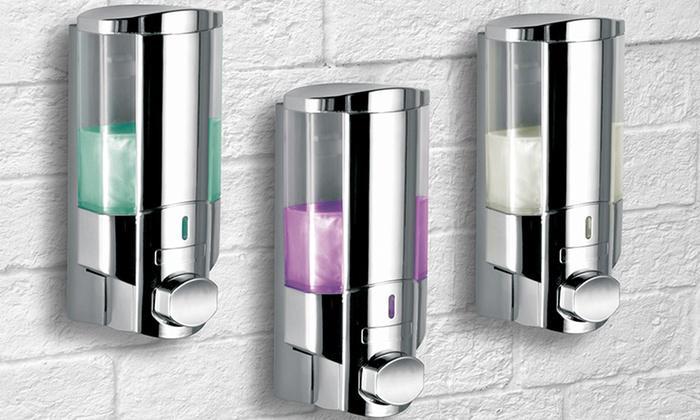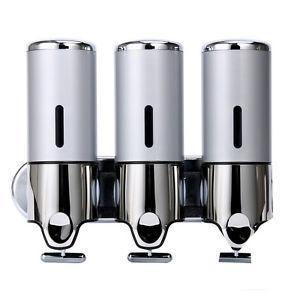The first image is the image on the left, the second image is the image on the right. For the images shown, is this caption "blue liquid is on the far left dispenser" true? Answer yes or no. No. 